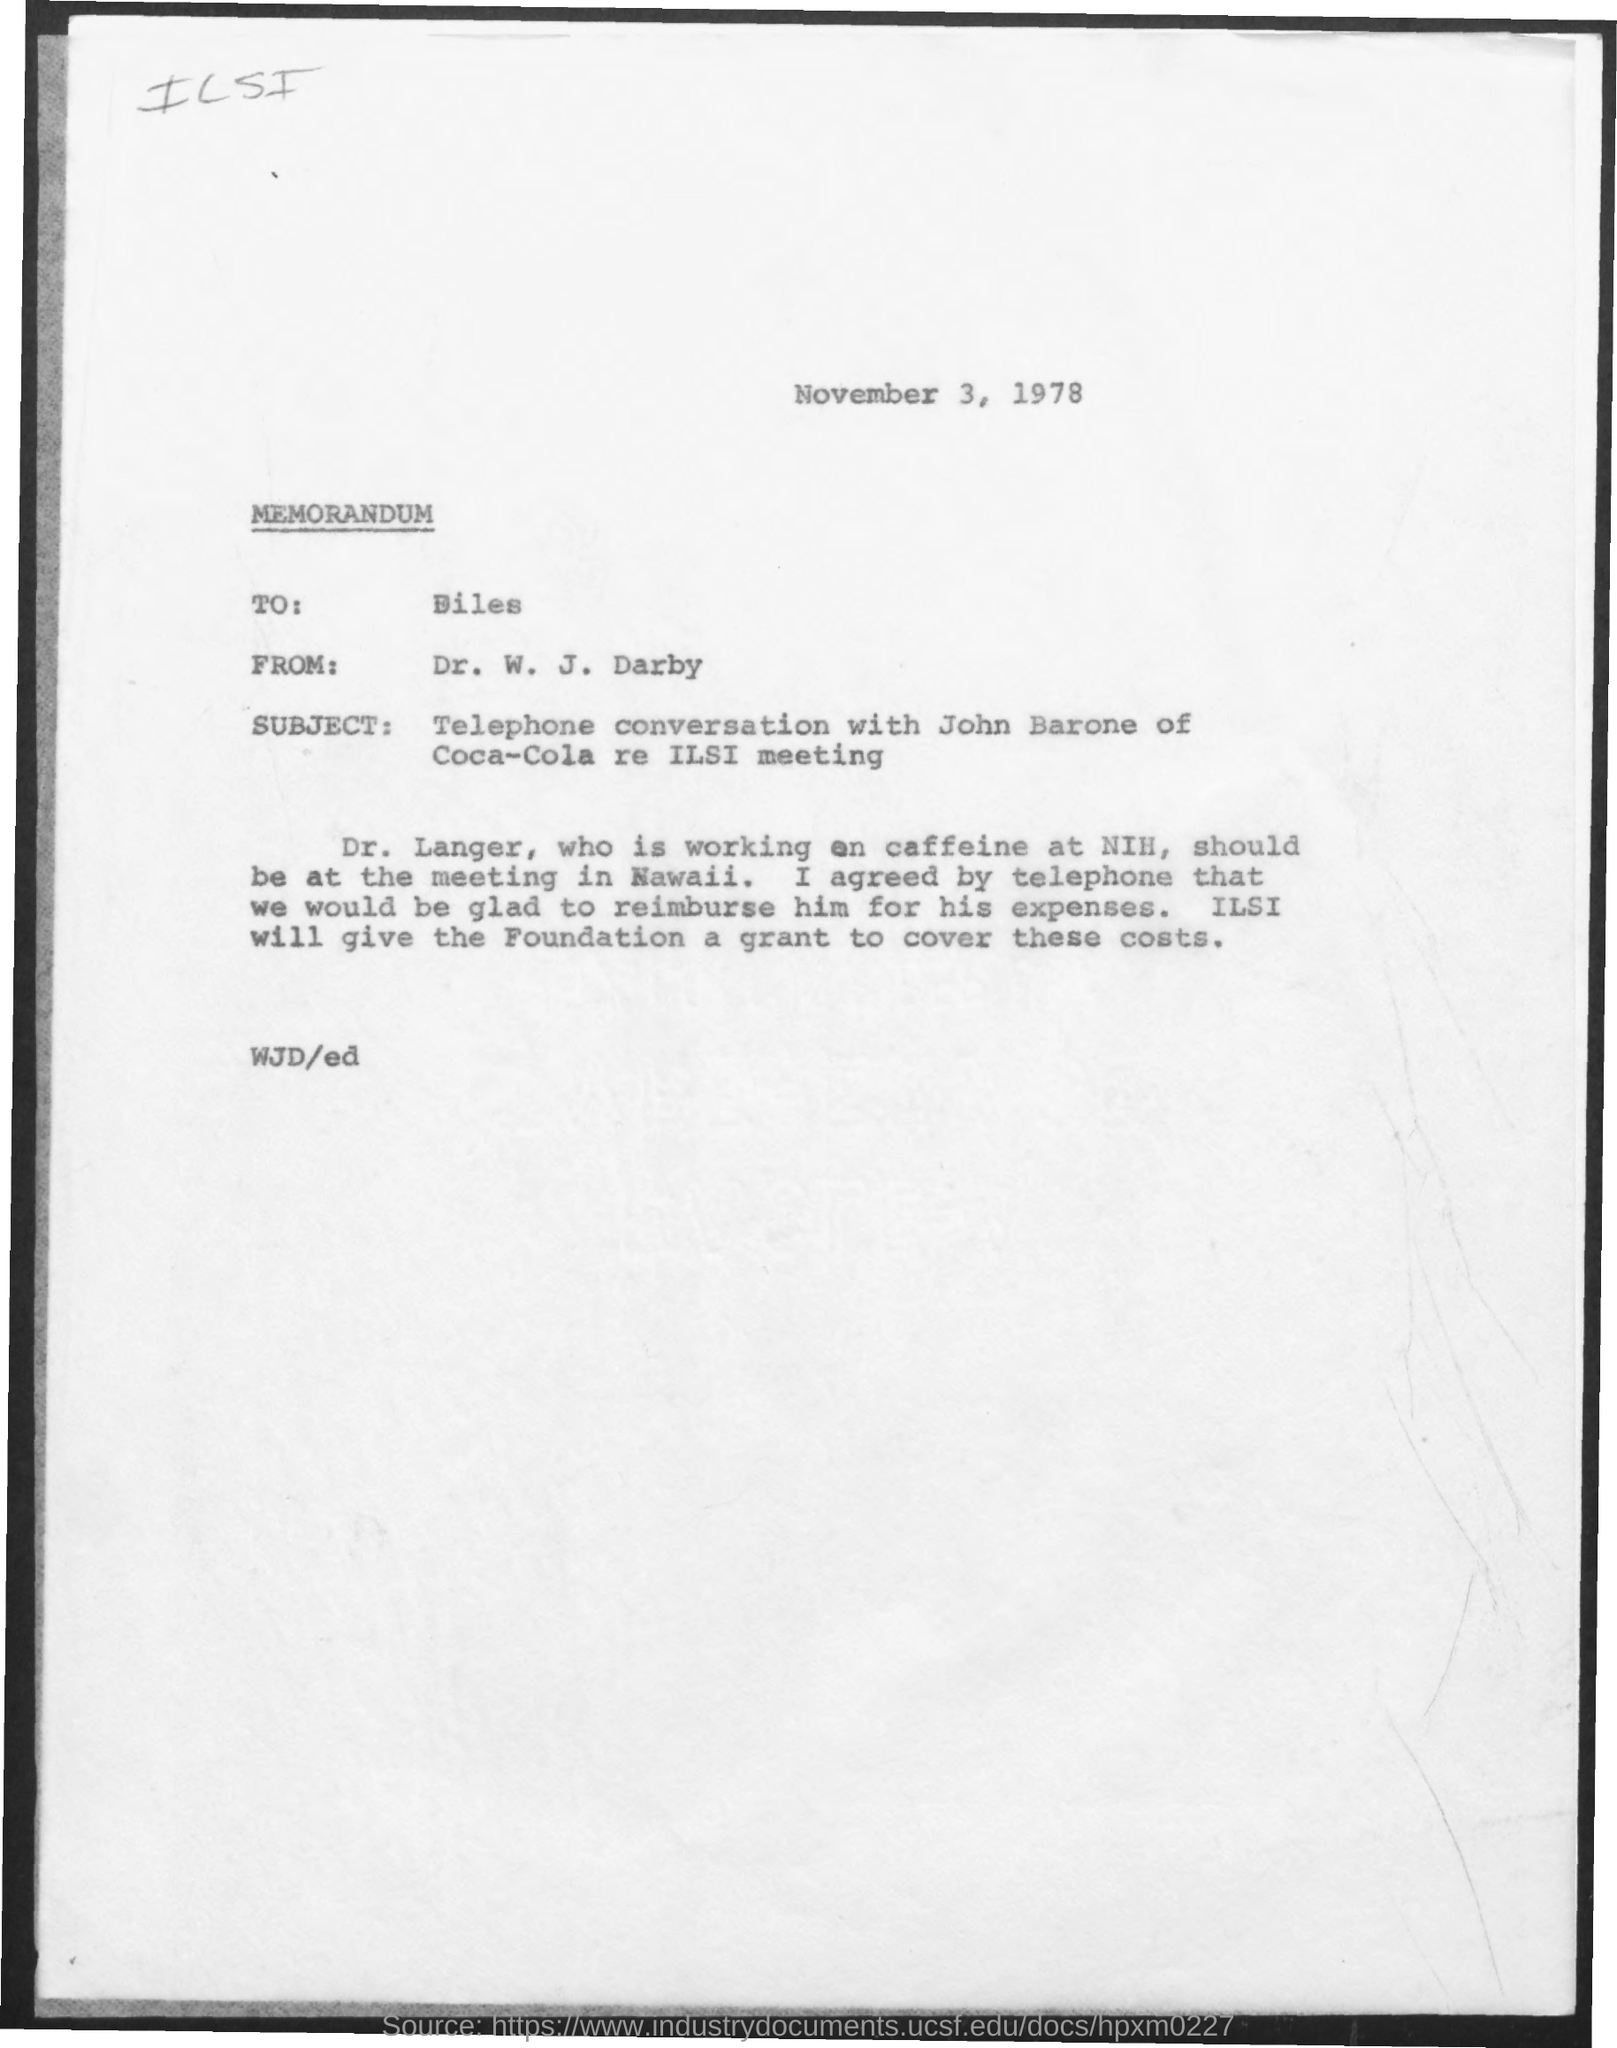Mention a couple of crucial points in this snapshot. The memorandum is addressed to Mr. Biles. 